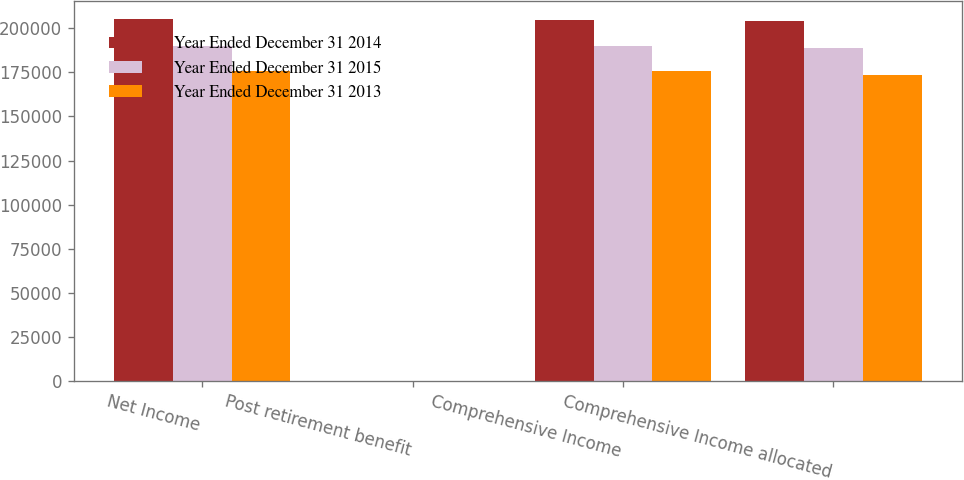<chart> <loc_0><loc_0><loc_500><loc_500><stacked_bar_chart><ecel><fcel>Net Income<fcel>Post retirement benefit<fcel>Comprehensive Income<fcel>Comprehensive Income allocated<nl><fcel>Year Ended December 31 2014<fcel>205023<fcel>135<fcel>204888<fcel>203990<nl><fcel>Year Ended December 31 2015<fcel>189714<fcel>361<fcel>190075<fcel>188753<nl><fcel>Year Ended December 31 2013<fcel>175999<fcel>157<fcel>175842<fcel>173706<nl></chart> 